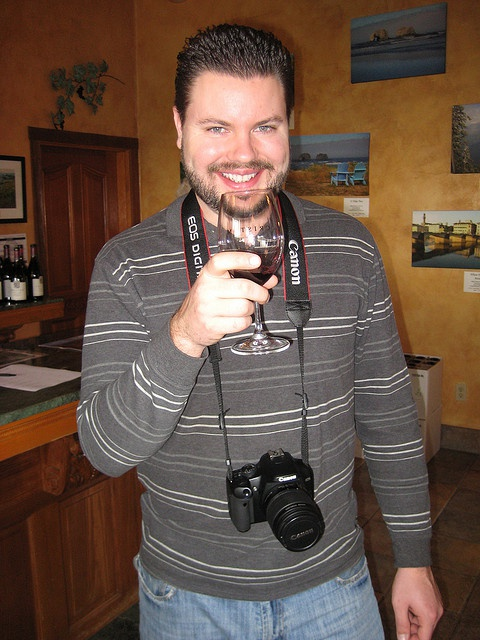Describe the objects in this image and their specific colors. I can see people in maroon, gray, black, darkgray, and lightpink tones, wine glass in maroon, gray, and lightpink tones, bottle in maroon, black, darkgray, and gray tones, bottle in maroon, black, darkgray, and gray tones, and bottle in maroon, black, and gray tones in this image. 